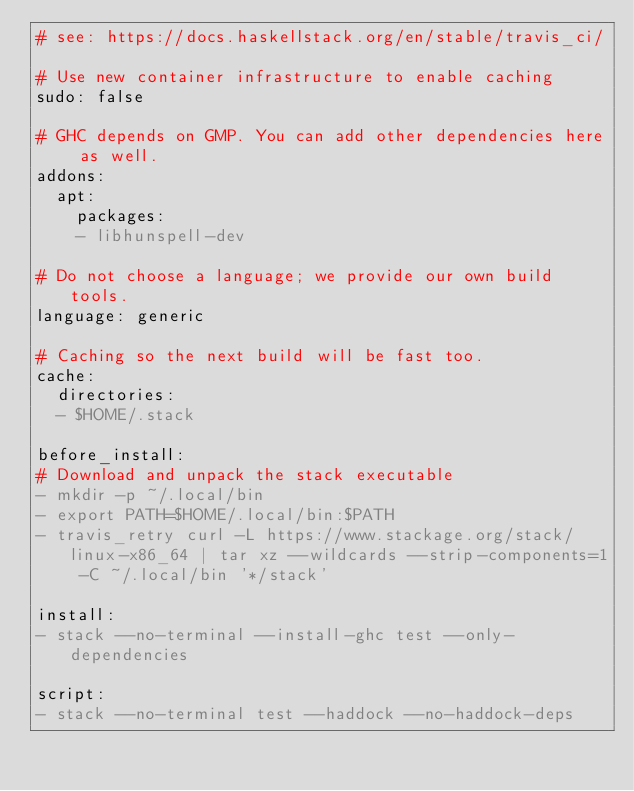Convert code to text. <code><loc_0><loc_0><loc_500><loc_500><_YAML_># see: https://docs.haskellstack.org/en/stable/travis_ci/

# Use new container infrastructure to enable caching
sudo: false

# GHC depends on GMP. You can add other dependencies here as well.
addons:
  apt:
    packages:
    - libhunspell-dev

# Do not choose a language; we provide our own build tools.
language: generic

# Caching so the next build will be fast too.
cache:
  directories:
  - $HOME/.stack

before_install:
# Download and unpack the stack executable
- mkdir -p ~/.local/bin
- export PATH=$HOME/.local/bin:$PATH
- travis_retry curl -L https://www.stackage.org/stack/linux-x86_64 | tar xz --wildcards --strip-components=1 -C ~/.local/bin '*/stack'

install:
- stack --no-terminal --install-ghc test --only-dependencies

script:
- stack --no-terminal test --haddock --no-haddock-deps
</code> 